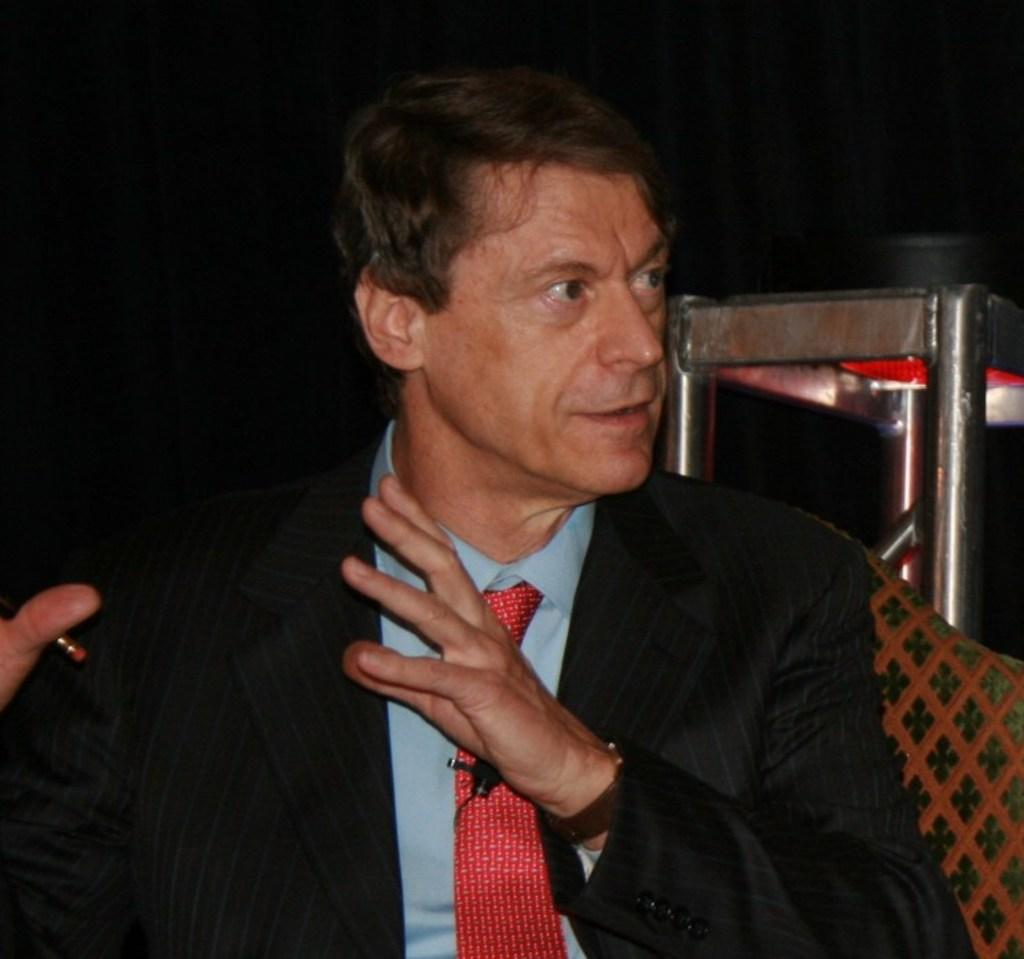Who is present in the image? There is a man in the image. What is the man doing in the image? The man is sitting on a sofa and appears to be speaking. What is the man wearing in the image? The man is wearing a suit and tie. What can be seen in the top right side of the image? There is a stainless steel table in the top right side of the image. What type of fowl is sitting on the man's shoulder in the image? There is no fowl present in the image; the man is sitting alone on the sofa. 